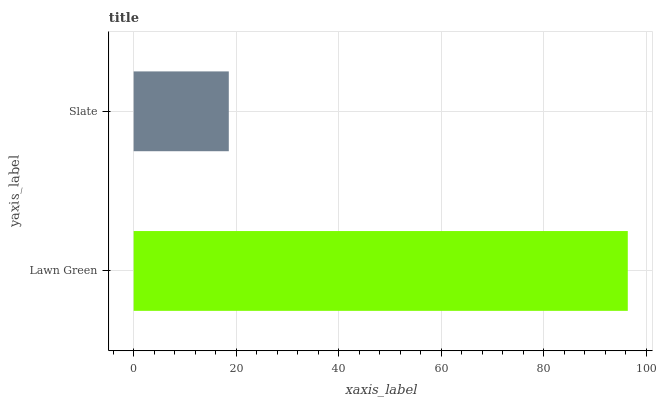Is Slate the minimum?
Answer yes or no. Yes. Is Lawn Green the maximum?
Answer yes or no. Yes. Is Slate the maximum?
Answer yes or no. No. Is Lawn Green greater than Slate?
Answer yes or no. Yes. Is Slate less than Lawn Green?
Answer yes or no. Yes. Is Slate greater than Lawn Green?
Answer yes or no. No. Is Lawn Green less than Slate?
Answer yes or no. No. Is Lawn Green the high median?
Answer yes or no. Yes. Is Slate the low median?
Answer yes or no. Yes. Is Slate the high median?
Answer yes or no. No. Is Lawn Green the low median?
Answer yes or no. No. 